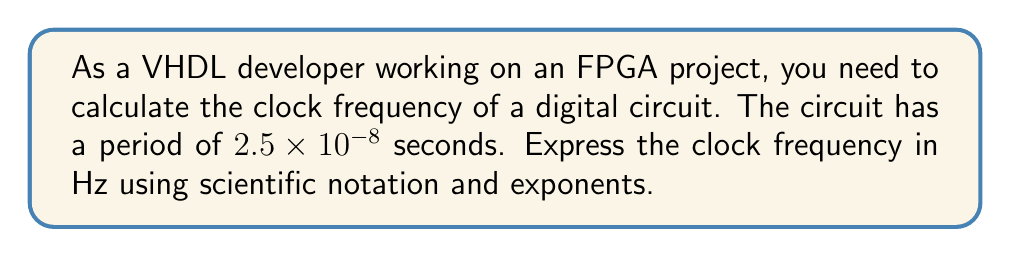Can you solve this math problem? To solve this problem, we'll follow these steps:

1) Recall that frequency ($f$) is the inverse of period ($T$):

   $$f = \frac{1}{T}$$

2) We're given the period $T = 2.5 \times 10^{-8}$ seconds. Let's substitute this into our equation:

   $$f = \frac{1}{2.5 \times 10^{-8}}$$

3) To calculate this, we can use the rules of exponents. When dividing by a number in scientific notation, we invert the base and subtract the exponent from -1:

   $$f = (2.5 \times 10^{-8})^{-1} = \frac{1}{2.5} \times 10^{-(-8)} = 0.4 \times 10^8$$

4) To express this in proper scientific notation, we need to move the decimal point one place to the right and decrease the exponent by 1:

   $$f = 4.0 \times 10^7 \text{ Hz}$$

This result gives us the frequency in Hz (which is equivalent to $\text{s}^{-1}$).
Answer: $4.0 \times 10^7 \text{ Hz}$ 